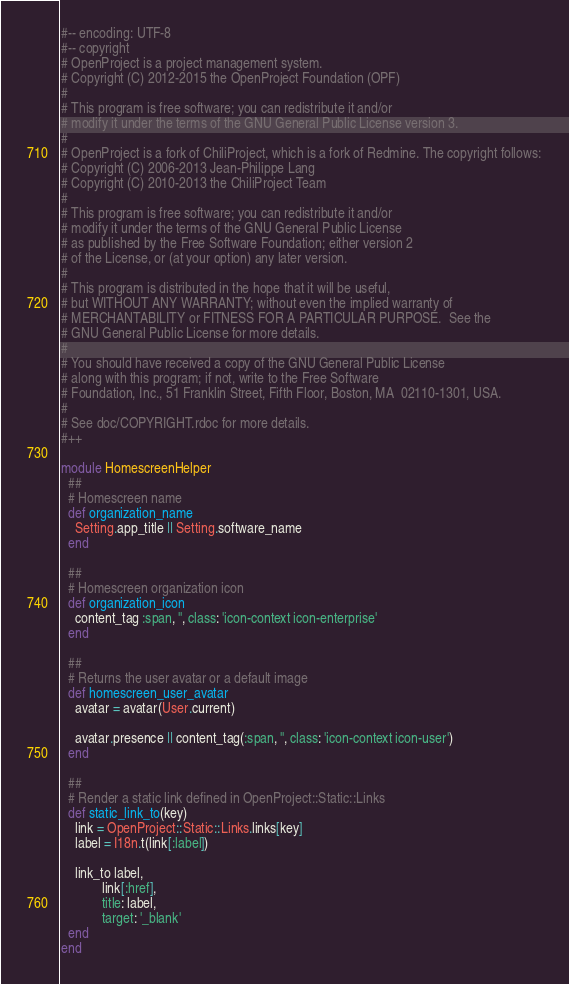Convert code to text. <code><loc_0><loc_0><loc_500><loc_500><_Ruby_>#-- encoding: UTF-8
#-- copyright
# OpenProject is a project management system.
# Copyright (C) 2012-2015 the OpenProject Foundation (OPF)
#
# This program is free software; you can redistribute it and/or
# modify it under the terms of the GNU General Public License version 3.
#
# OpenProject is a fork of ChiliProject, which is a fork of Redmine. The copyright follows:
# Copyright (C) 2006-2013 Jean-Philippe Lang
# Copyright (C) 2010-2013 the ChiliProject Team
#
# This program is free software; you can redistribute it and/or
# modify it under the terms of the GNU General Public License
# as published by the Free Software Foundation; either version 2
# of the License, or (at your option) any later version.
#
# This program is distributed in the hope that it will be useful,
# but WITHOUT ANY WARRANTY; without even the implied warranty of
# MERCHANTABILITY or FITNESS FOR A PARTICULAR PURPOSE.  See the
# GNU General Public License for more details.
#
# You should have received a copy of the GNU General Public License
# along with this program; if not, write to the Free Software
# Foundation, Inc., 51 Franklin Street, Fifth Floor, Boston, MA  02110-1301, USA.
#
# See doc/COPYRIGHT.rdoc for more details.
#++

module HomescreenHelper
  ##
  # Homescreen name
  def organization_name
    Setting.app_title || Setting.software_name
  end

  ##
  # Homescreen organization icon
  def organization_icon
    content_tag :span, '', class: 'icon-context icon-enterprise'
  end

  ##
  # Returns the user avatar or a default image
  def homescreen_user_avatar
    avatar = avatar(User.current)

    avatar.presence || content_tag(:span, '', class: 'icon-context icon-user')
  end

  ##
  # Render a static link defined in OpenProject::Static::Links
  def static_link_to(key)
    link = OpenProject::Static::Links.links[key]
    label = I18n.t(link[:label])

    link_to label,
            link[:href],
            title: label,
            target: '_blank'
  end
end
</code> 